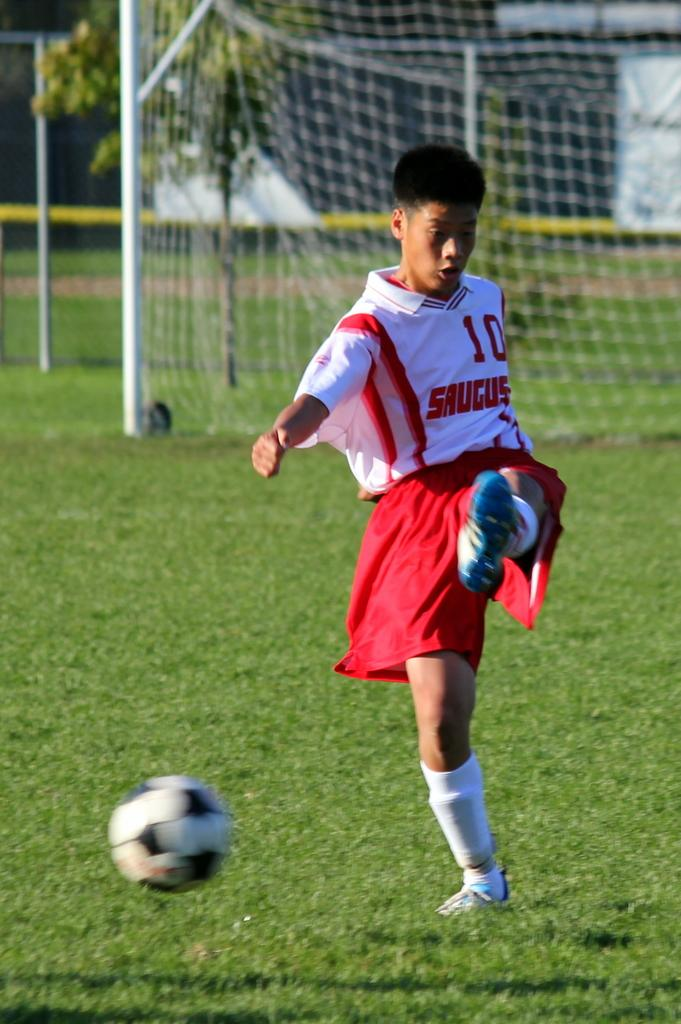What is the person in the image doing? The person is playing football. What is the person wearing while playing football? The person is wearing a white and red color dress. What is in the air in the image? There is a football in the air. What can be seen in the background of the image? There is a net and rods in the background of the image. What type of milk is being poured into the sleet in the image? There is no milk or sleet present in the image; it features a person playing football with a football in the air. 